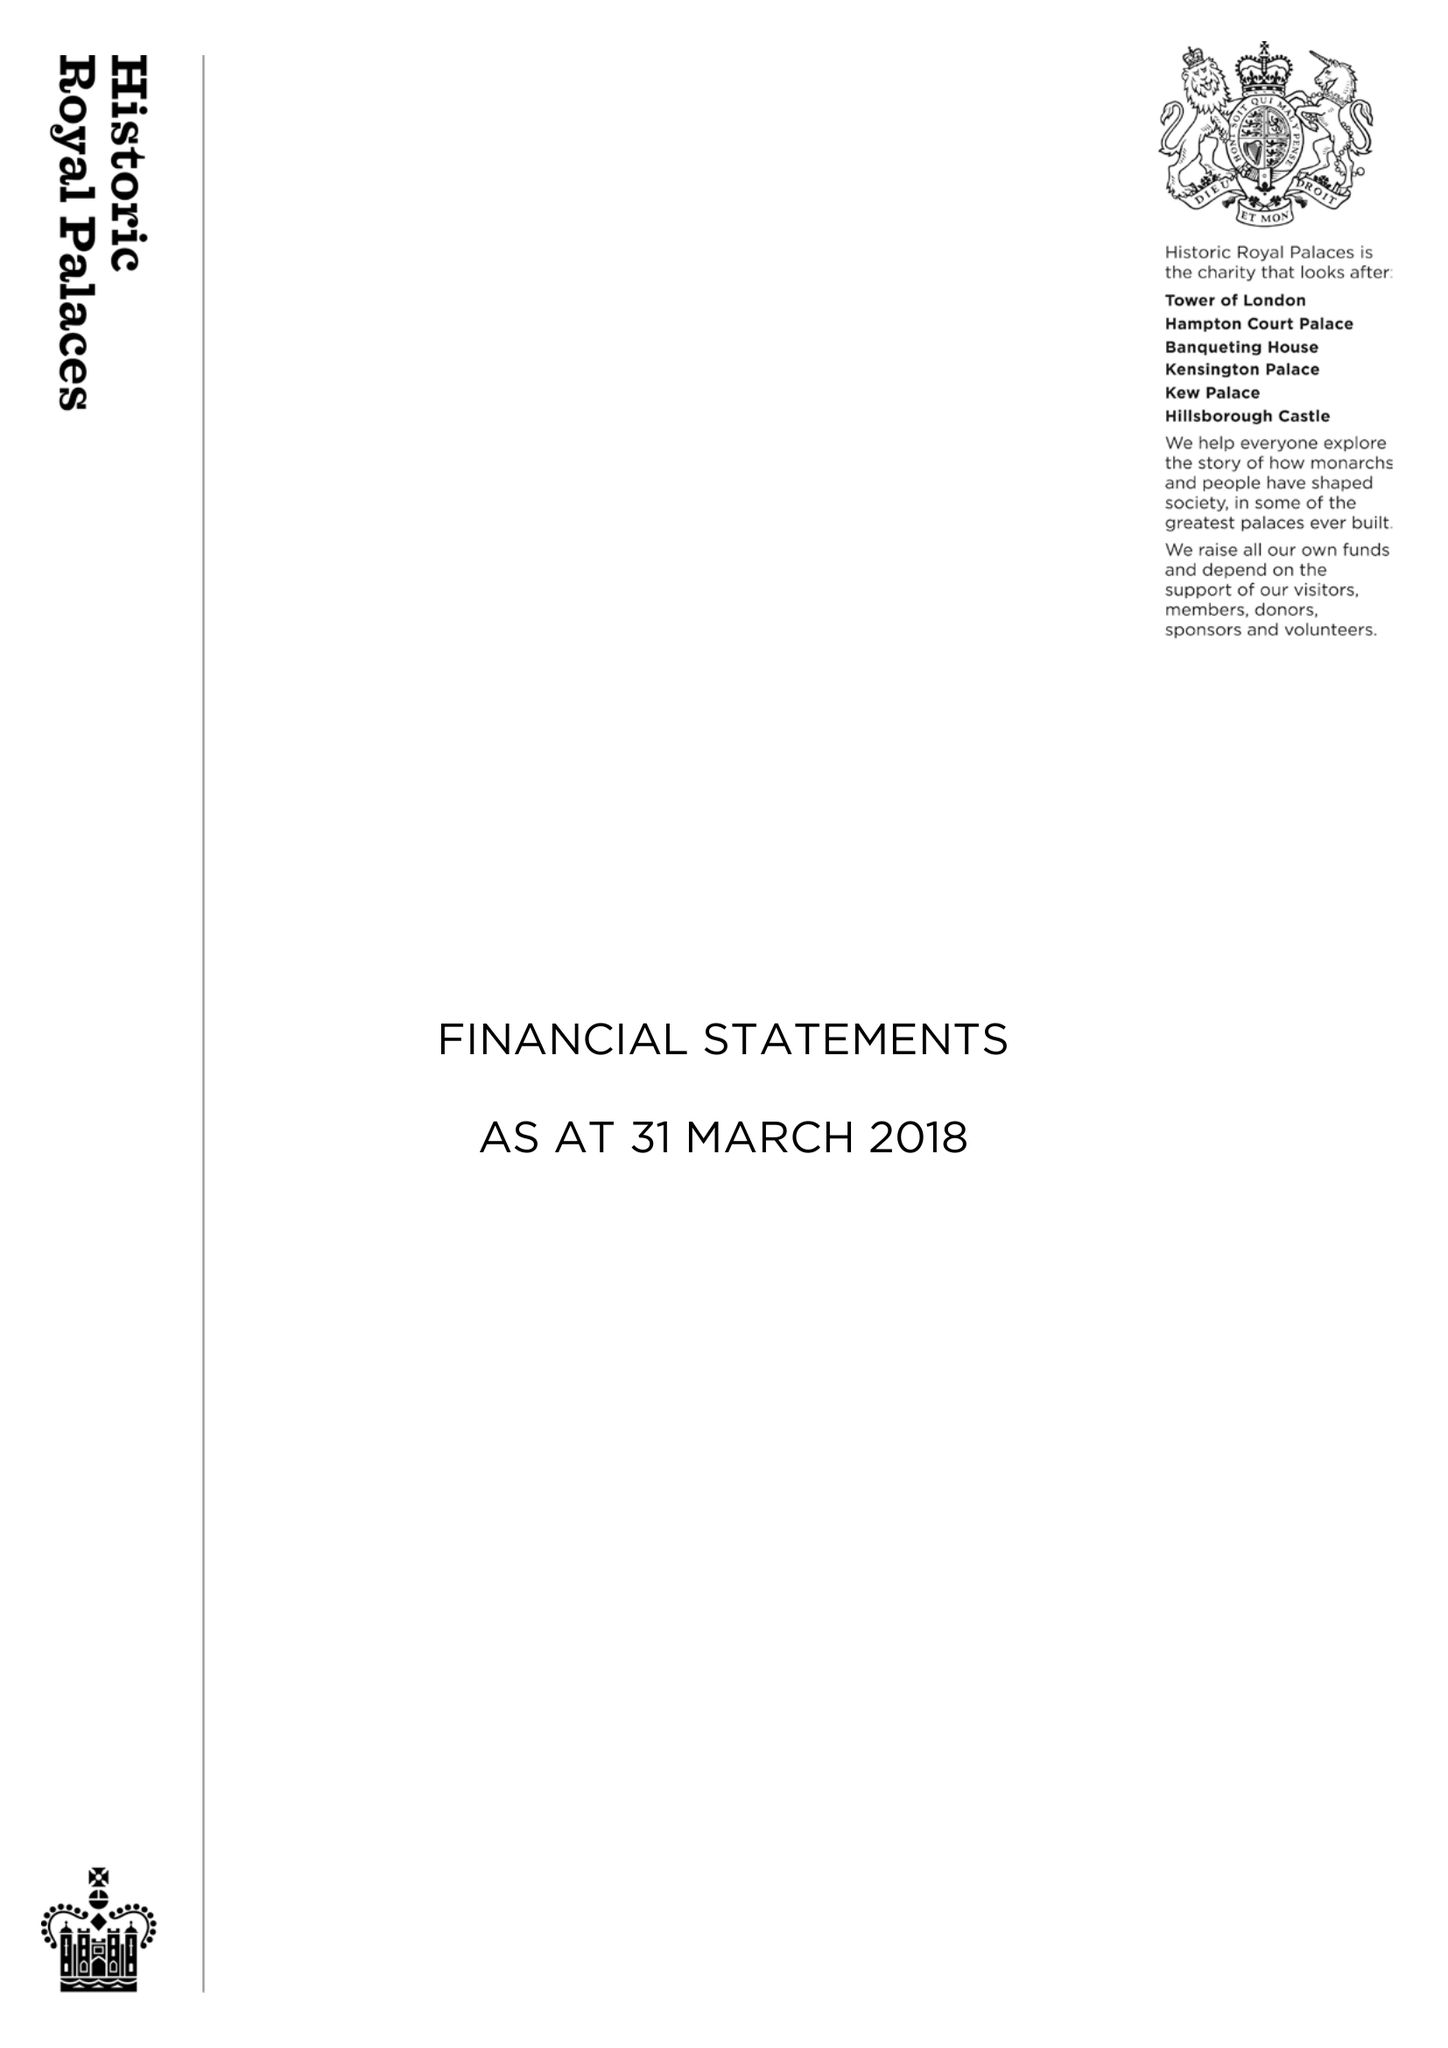What is the value for the address__postcode?
Answer the question using a single word or phrase. KT8 9AU 